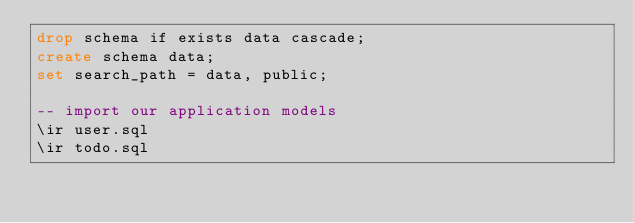Convert code to text. <code><loc_0><loc_0><loc_500><loc_500><_SQL_>drop schema if exists data cascade;
create schema data;
set search_path = data, public;

-- import our application models
\ir user.sql
\ir todo.sql
</code> 